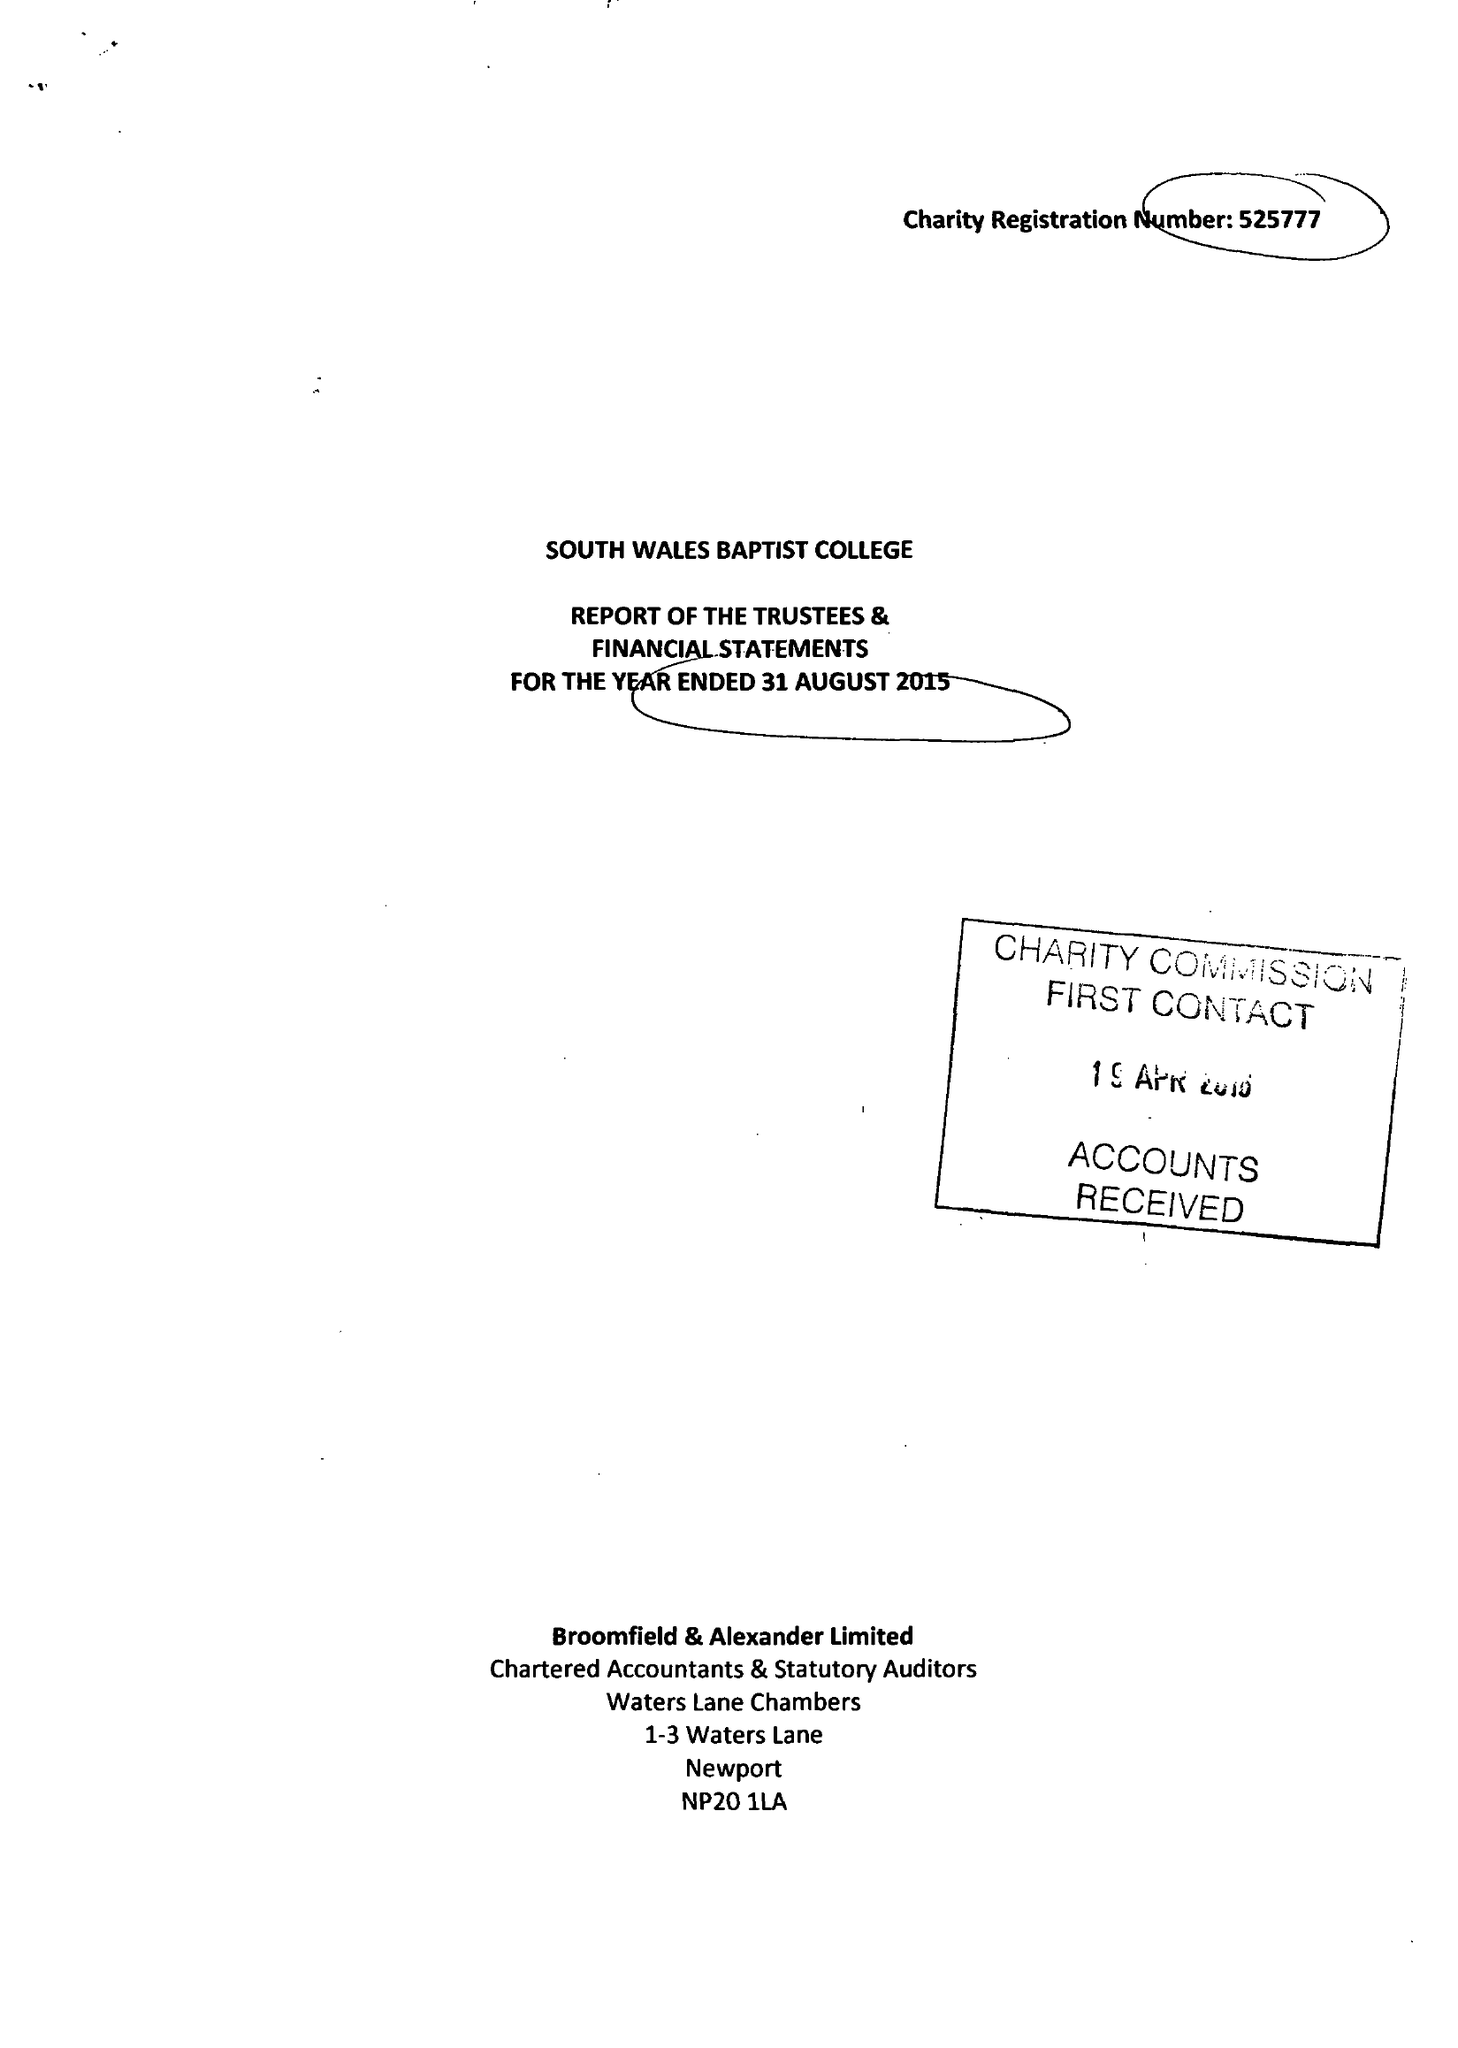What is the value for the spending_annually_in_british_pounds?
Answer the question using a single word or phrase. 469017.00 